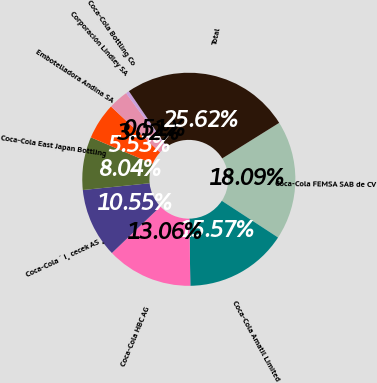<chart> <loc_0><loc_0><loc_500><loc_500><pie_chart><fcel>Coca-Cola FEMSA SAB de CV<fcel>Coca-Cola Amatil Limited<fcel>Coca-Cola HBC AG<fcel>Coca-Cola ˙ I¸ cecek AS ¸<fcel>Coca-Cola East Japan Bottling<fcel>Embotelladora Andina SA<fcel>Corporación Lindley SA<fcel>Coca-Cola Bottling Co<fcel>Total<nl><fcel>18.08%<fcel>15.57%<fcel>13.06%<fcel>10.55%<fcel>8.04%<fcel>5.53%<fcel>3.02%<fcel>0.51%<fcel>25.61%<nl></chart> 